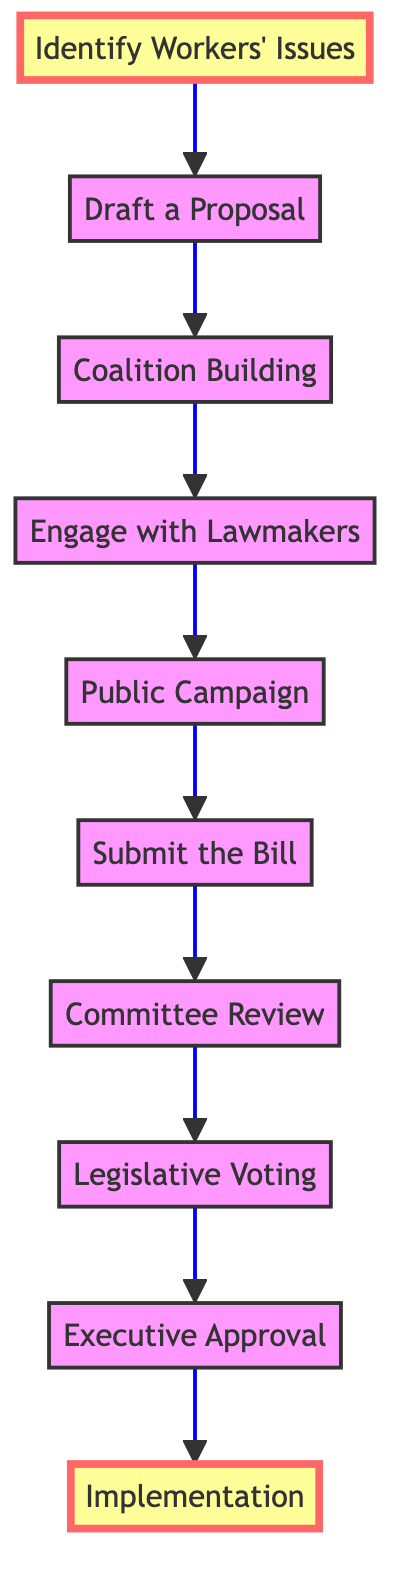What is the first step in advocating for workers' rights according to the diagram? The first step is labeled "Identify Workers' Issues," which indicates that understanding the primary concerns of union members is the initial action required.
Answer: Identify Workers' Issues How many total steps are involved in the process shown in the diagram? By counting each node in the flow chart, we see that there are ten distinct steps from "Identify Workers' Issues" to "Implementation".
Answer: 10 What action is taken after "Submit the Bill"? After "Submit the Bill," the next action is "Committee Review,” which shows that the legislation enters the committee stage for evaluation.
Answer: Committee Review Which step involves collaboration with union leadership? The step "Draft a Proposal" mentions collaboration with union leadership to create a legislative proposal, making it the specific step where this occurs.
Answer: Draft a Proposal What is the last step in the process? The last step listed in the flow chart is "Implementation," indicating that the final action is ensuring that the law is properly enforced and put into practice.
Answer: Implementation What kind of campaign is organized before submitting the bill? The organized campaign referred to is the "Public Campaign," which is designed to raise awareness and support for the legislation prior to its formal submission.
Answer: Public Campaign How does coalition building relate to engaging with lawmakers? Coalition Building occurs prior to engaging with lawmakers; it establishes a supportive base that enhances the efficacy of the following engagement efforts with legislators.
Answer: Coalition Building What type of approval follows legislative voting? After "Legislative Voting," the diagram indicates "Executive Approval" as the necessary next step, which is essential for the bill to become law.
Answer: Executive Approval What role do lawmakers play at the stage called "Engage with Lawmakers"? In the "Engage with Lawmakers" step, the role of lawmakers is to be informed and gain support for the proposed legislation, demonstrating a critical interaction between proponents and legislators.
Answer: Engage with Lawmakers 